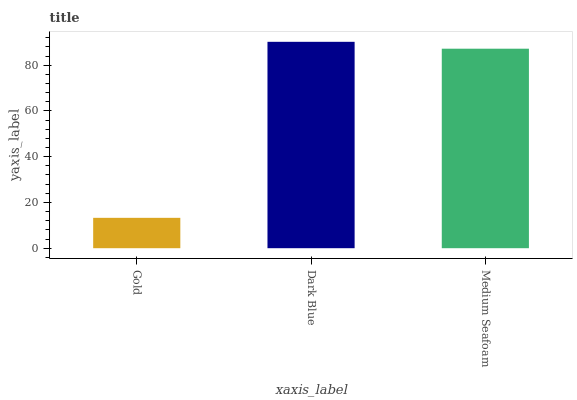Is Gold the minimum?
Answer yes or no. Yes. Is Dark Blue the maximum?
Answer yes or no. Yes. Is Medium Seafoam the minimum?
Answer yes or no. No. Is Medium Seafoam the maximum?
Answer yes or no. No. Is Dark Blue greater than Medium Seafoam?
Answer yes or no. Yes. Is Medium Seafoam less than Dark Blue?
Answer yes or no. Yes. Is Medium Seafoam greater than Dark Blue?
Answer yes or no. No. Is Dark Blue less than Medium Seafoam?
Answer yes or no. No. Is Medium Seafoam the high median?
Answer yes or no. Yes. Is Medium Seafoam the low median?
Answer yes or no. Yes. Is Dark Blue the high median?
Answer yes or no. No. Is Dark Blue the low median?
Answer yes or no. No. 